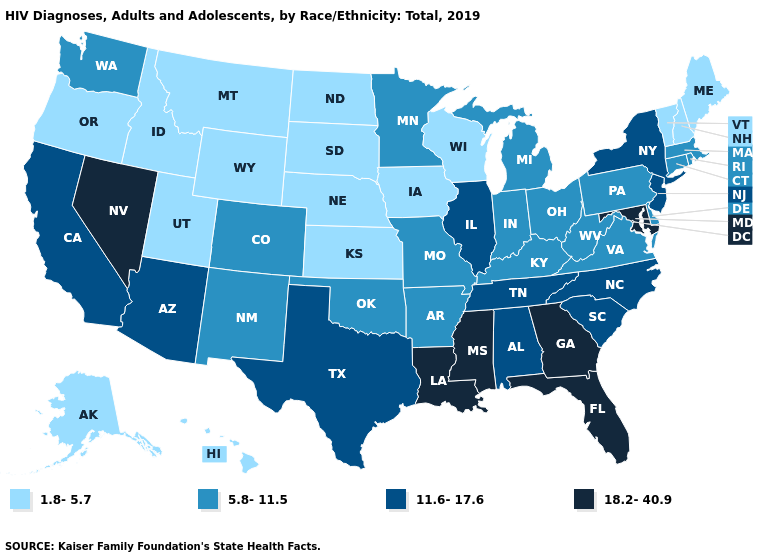Is the legend a continuous bar?
Concise answer only. No. Which states hav the highest value in the Northeast?
Concise answer only. New Jersey, New York. Which states have the lowest value in the USA?
Quick response, please. Alaska, Hawaii, Idaho, Iowa, Kansas, Maine, Montana, Nebraska, New Hampshire, North Dakota, Oregon, South Dakota, Utah, Vermont, Wisconsin, Wyoming. What is the value of Kentucky?
Quick response, please. 5.8-11.5. Name the states that have a value in the range 5.8-11.5?
Short answer required. Arkansas, Colorado, Connecticut, Delaware, Indiana, Kentucky, Massachusetts, Michigan, Minnesota, Missouri, New Mexico, Ohio, Oklahoma, Pennsylvania, Rhode Island, Virginia, Washington, West Virginia. Among the states that border Kentucky , which have the lowest value?
Quick response, please. Indiana, Missouri, Ohio, Virginia, West Virginia. Name the states that have a value in the range 18.2-40.9?
Keep it brief. Florida, Georgia, Louisiana, Maryland, Mississippi, Nevada. What is the value of Pennsylvania?
Concise answer only. 5.8-11.5. Does Iowa have the lowest value in the MidWest?
Answer briefly. Yes. Does North Dakota have the lowest value in the MidWest?
Write a very short answer. Yes. Which states have the highest value in the USA?
Answer briefly. Florida, Georgia, Louisiana, Maryland, Mississippi, Nevada. Does Idaho have the lowest value in the West?
Keep it brief. Yes. What is the value of West Virginia?
Keep it brief. 5.8-11.5. Name the states that have a value in the range 1.8-5.7?
Concise answer only. Alaska, Hawaii, Idaho, Iowa, Kansas, Maine, Montana, Nebraska, New Hampshire, North Dakota, Oregon, South Dakota, Utah, Vermont, Wisconsin, Wyoming. 